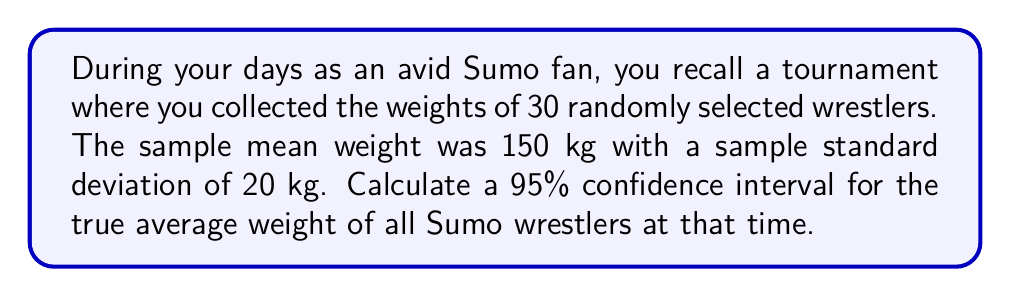Solve this math problem. To calculate the confidence interval, we'll follow these steps:

1) We're using a sample to estimate the population mean, so we'll use the t-distribution.

2) For a 95% confidence interval with 29 degrees of freedom (n-1 = 30-1 = 29), the t-value is approximately 2.045.

3) The formula for the confidence interval is:

   $$\bar{x} \pm t_{\alpha/2} \cdot \frac{s}{\sqrt{n}}$$

   Where:
   $\bar{x}$ is the sample mean (150 kg)
   $s$ is the sample standard deviation (20 kg)
   $n$ is the sample size (30)
   $t_{\alpha/2}$ is the t-value (2.045)

4) Let's calculate the margin of error:

   $$\text{Margin of Error} = t_{\alpha/2} \cdot \frac{s}{\sqrt{n}} = 2.045 \cdot \frac{20}{\sqrt{30}} \approx 7.47$$

5) Now, we can calculate the confidence interval:

   Lower bound: $150 - 7.47 = 142.53$ kg
   Upper bound: $150 + 7.47 = 157.47$ kg

6) Rounding to one decimal place for practical purposes:

   95% CI: (142.5 kg, 157.5 kg)

This means we can be 95% confident that the true average weight of all Sumo wrestlers at that time was between 142.5 kg and 157.5 kg.
Answer: (142.5 kg, 157.5 kg) 